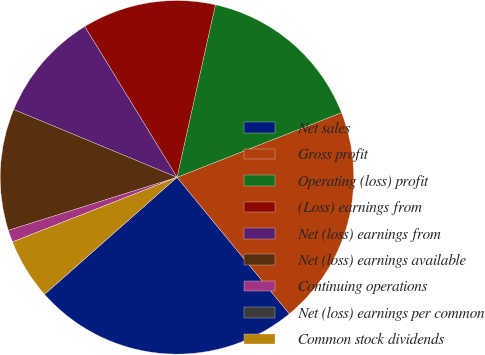Convert chart. <chart><loc_0><loc_0><loc_500><loc_500><pie_chart><fcel>Net sales<fcel>Gross profit<fcel>Operating (loss) profit<fcel>(Loss) earnings from<fcel>Net (loss) earnings from<fcel>Net (loss) earnings available<fcel>Continuing operations<fcel>Net (loss) earnings per common<fcel>Common stock dividends<nl><fcel>24.44%<fcel>20.0%<fcel>15.55%<fcel>12.22%<fcel>10.0%<fcel>11.11%<fcel>1.11%<fcel>0.0%<fcel>5.56%<nl></chart> 